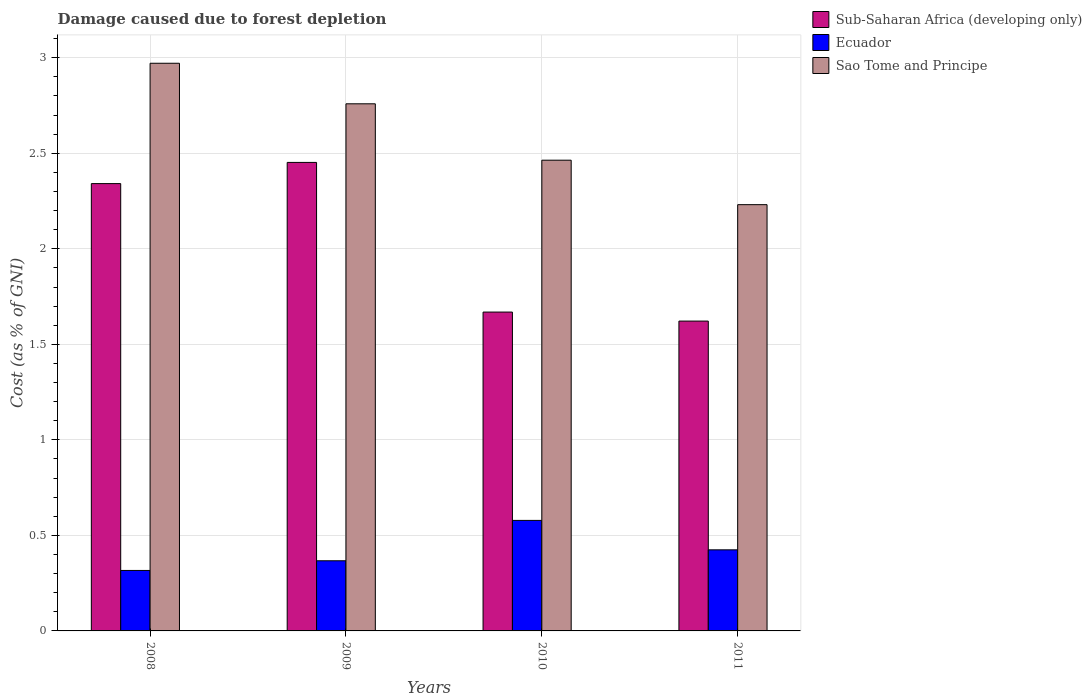How many bars are there on the 1st tick from the left?
Offer a terse response. 3. How many bars are there on the 1st tick from the right?
Your answer should be compact. 3. In how many cases, is the number of bars for a given year not equal to the number of legend labels?
Keep it short and to the point. 0. What is the cost of damage caused due to forest depletion in Sub-Saharan Africa (developing only) in 2008?
Provide a short and direct response. 2.34. Across all years, what is the maximum cost of damage caused due to forest depletion in Sub-Saharan Africa (developing only)?
Keep it short and to the point. 2.45. Across all years, what is the minimum cost of damage caused due to forest depletion in Sao Tome and Principe?
Keep it short and to the point. 2.23. In which year was the cost of damage caused due to forest depletion in Ecuador maximum?
Offer a very short reply. 2010. In which year was the cost of damage caused due to forest depletion in Sao Tome and Principe minimum?
Your answer should be very brief. 2011. What is the total cost of damage caused due to forest depletion in Sao Tome and Principe in the graph?
Your answer should be compact. 10.42. What is the difference between the cost of damage caused due to forest depletion in Sub-Saharan Africa (developing only) in 2008 and that in 2010?
Keep it short and to the point. 0.67. What is the difference between the cost of damage caused due to forest depletion in Ecuador in 2010 and the cost of damage caused due to forest depletion in Sao Tome and Principe in 2009?
Your answer should be very brief. -2.18. What is the average cost of damage caused due to forest depletion in Sub-Saharan Africa (developing only) per year?
Make the answer very short. 2.02. In the year 2009, what is the difference between the cost of damage caused due to forest depletion in Sub-Saharan Africa (developing only) and cost of damage caused due to forest depletion in Sao Tome and Principe?
Offer a terse response. -0.31. What is the ratio of the cost of damage caused due to forest depletion in Ecuador in 2010 to that in 2011?
Provide a succinct answer. 1.36. Is the cost of damage caused due to forest depletion in Sub-Saharan Africa (developing only) in 2009 less than that in 2010?
Keep it short and to the point. No. Is the difference between the cost of damage caused due to forest depletion in Sub-Saharan Africa (developing only) in 2009 and 2010 greater than the difference between the cost of damage caused due to forest depletion in Sao Tome and Principe in 2009 and 2010?
Your response must be concise. Yes. What is the difference between the highest and the second highest cost of damage caused due to forest depletion in Ecuador?
Ensure brevity in your answer.  0.15. What is the difference between the highest and the lowest cost of damage caused due to forest depletion in Sao Tome and Principe?
Give a very brief answer. 0.74. In how many years, is the cost of damage caused due to forest depletion in Sao Tome and Principe greater than the average cost of damage caused due to forest depletion in Sao Tome and Principe taken over all years?
Your answer should be compact. 2. What does the 2nd bar from the left in 2009 represents?
Make the answer very short. Ecuador. What does the 2nd bar from the right in 2011 represents?
Your response must be concise. Ecuador. Are all the bars in the graph horizontal?
Give a very brief answer. No. Does the graph contain any zero values?
Your answer should be compact. No. What is the title of the graph?
Your answer should be very brief. Damage caused due to forest depletion. What is the label or title of the X-axis?
Keep it short and to the point. Years. What is the label or title of the Y-axis?
Provide a succinct answer. Cost (as % of GNI). What is the Cost (as % of GNI) in Sub-Saharan Africa (developing only) in 2008?
Your answer should be compact. 2.34. What is the Cost (as % of GNI) in Ecuador in 2008?
Your answer should be compact. 0.32. What is the Cost (as % of GNI) of Sao Tome and Principe in 2008?
Provide a succinct answer. 2.97. What is the Cost (as % of GNI) in Sub-Saharan Africa (developing only) in 2009?
Provide a short and direct response. 2.45. What is the Cost (as % of GNI) in Ecuador in 2009?
Offer a terse response. 0.37. What is the Cost (as % of GNI) of Sao Tome and Principe in 2009?
Provide a succinct answer. 2.76. What is the Cost (as % of GNI) of Sub-Saharan Africa (developing only) in 2010?
Ensure brevity in your answer.  1.67. What is the Cost (as % of GNI) of Ecuador in 2010?
Offer a very short reply. 0.58. What is the Cost (as % of GNI) of Sao Tome and Principe in 2010?
Keep it short and to the point. 2.46. What is the Cost (as % of GNI) in Sub-Saharan Africa (developing only) in 2011?
Provide a short and direct response. 1.62. What is the Cost (as % of GNI) of Ecuador in 2011?
Give a very brief answer. 0.42. What is the Cost (as % of GNI) of Sao Tome and Principe in 2011?
Your answer should be very brief. 2.23. Across all years, what is the maximum Cost (as % of GNI) of Sub-Saharan Africa (developing only)?
Your response must be concise. 2.45. Across all years, what is the maximum Cost (as % of GNI) of Ecuador?
Your response must be concise. 0.58. Across all years, what is the maximum Cost (as % of GNI) in Sao Tome and Principe?
Your answer should be very brief. 2.97. Across all years, what is the minimum Cost (as % of GNI) of Sub-Saharan Africa (developing only)?
Offer a terse response. 1.62. Across all years, what is the minimum Cost (as % of GNI) of Ecuador?
Offer a terse response. 0.32. Across all years, what is the minimum Cost (as % of GNI) of Sao Tome and Principe?
Provide a succinct answer. 2.23. What is the total Cost (as % of GNI) of Sub-Saharan Africa (developing only) in the graph?
Your response must be concise. 8.08. What is the total Cost (as % of GNI) in Ecuador in the graph?
Offer a very short reply. 1.69. What is the total Cost (as % of GNI) of Sao Tome and Principe in the graph?
Provide a short and direct response. 10.42. What is the difference between the Cost (as % of GNI) of Sub-Saharan Africa (developing only) in 2008 and that in 2009?
Provide a succinct answer. -0.11. What is the difference between the Cost (as % of GNI) of Ecuador in 2008 and that in 2009?
Ensure brevity in your answer.  -0.05. What is the difference between the Cost (as % of GNI) of Sao Tome and Principe in 2008 and that in 2009?
Offer a very short reply. 0.21. What is the difference between the Cost (as % of GNI) in Sub-Saharan Africa (developing only) in 2008 and that in 2010?
Your answer should be very brief. 0.67. What is the difference between the Cost (as % of GNI) in Ecuador in 2008 and that in 2010?
Your answer should be compact. -0.26. What is the difference between the Cost (as % of GNI) of Sao Tome and Principe in 2008 and that in 2010?
Your response must be concise. 0.51. What is the difference between the Cost (as % of GNI) in Sub-Saharan Africa (developing only) in 2008 and that in 2011?
Keep it short and to the point. 0.72. What is the difference between the Cost (as % of GNI) in Ecuador in 2008 and that in 2011?
Your answer should be compact. -0.11. What is the difference between the Cost (as % of GNI) in Sao Tome and Principe in 2008 and that in 2011?
Your answer should be very brief. 0.74. What is the difference between the Cost (as % of GNI) of Sub-Saharan Africa (developing only) in 2009 and that in 2010?
Your answer should be compact. 0.78. What is the difference between the Cost (as % of GNI) of Ecuador in 2009 and that in 2010?
Your answer should be compact. -0.21. What is the difference between the Cost (as % of GNI) of Sao Tome and Principe in 2009 and that in 2010?
Your response must be concise. 0.3. What is the difference between the Cost (as % of GNI) in Sub-Saharan Africa (developing only) in 2009 and that in 2011?
Offer a terse response. 0.83. What is the difference between the Cost (as % of GNI) in Ecuador in 2009 and that in 2011?
Provide a succinct answer. -0.06. What is the difference between the Cost (as % of GNI) of Sao Tome and Principe in 2009 and that in 2011?
Offer a terse response. 0.53. What is the difference between the Cost (as % of GNI) in Sub-Saharan Africa (developing only) in 2010 and that in 2011?
Your response must be concise. 0.05. What is the difference between the Cost (as % of GNI) in Ecuador in 2010 and that in 2011?
Your response must be concise. 0.15. What is the difference between the Cost (as % of GNI) of Sao Tome and Principe in 2010 and that in 2011?
Make the answer very short. 0.23. What is the difference between the Cost (as % of GNI) of Sub-Saharan Africa (developing only) in 2008 and the Cost (as % of GNI) of Ecuador in 2009?
Your answer should be very brief. 1.97. What is the difference between the Cost (as % of GNI) of Sub-Saharan Africa (developing only) in 2008 and the Cost (as % of GNI) of Sao Tome and Principe in 2009?
Provide a succinct answer. -0.42. What is the difference between the Cost (as % of GNI) of Ecuador in 2008 and the Cost (as % of GNI) of Sao Tome and Principe in 2009?
Offer a terse response. -2.44. What is the difference between the Cost (as % of GNI) in Sub-Saharan Africa (developing only) in 2008 and the Cost (as % of GNI) in Ecuador in 2010?
Ensure brevity in your answer.  1.76. What is the difference between the Cost (as % of GNI) in Sub-Saharan Africa (developing only) in 2008 and the Cost (as % of GNI) in Sao Tome and Principe in 2010?
Offer a very short reply. -0.12. What is the difference between the Cost (as % of GNI) in Ecuador in 2008 and the Cost (as % of GNI) in Sao Tome and Principe in 2010?
Your answer should be compact. -2.15. What is the difference between the Cost (as % of GNI) in Sub-Saharan Africa (developing only) in 2008 and the Cost (as % of GNI) in Ecuador in 2011?
Your response must be concise. 1.92. What is the difference between the Cost (as % of GNI) in Sub-Saharan Africa (developing only) in 2008 and the Cost (as % of GNI) in Sao Tome and Principe in 2011?
Provide a short and direct response. 0.11. What is the difference between the Cost (as % of GNI) of Ecuador in 2008 and the Cost (as % of GNI) of Sao Tome and Principe in 2011?
Your answer should be very brief. -1.91. What is the difference between the Cost (as % of GNI) of Sub-Saharan Africa (developing only) in 2009 and the Cost (as % of GNI) of Ecuador in 2010?
Provide a succinct answer. 1.87. What is the difference between the Cost (as % of GNI) of Sub-Saharan Africa (developing only) in 2009 and the Cost (as % of GNI) of Sao Tome and Principe in 2010?
Your answer should be compact. -0.01. What is the difference between the Cost (as % of GNI) of Ecuador in 2009 and the Cost (as % of GNI) of Sao Tome and Principe in 2010?
Your answer should be compact. -2.1. What is the difference between the Cost (as % of GNI) in Sub-Saharan Africa (developing only) in 2009 and the Cost (as % of GNI) in Ecuador in 2011?
Your response must be concise. 2.03. What is the difference between the Cost (as % of GNI) of Sub-Saharan Africa (developing only) in 2009 and the Cost (as % of GNI) of Sao Tome and Principe in 2011?
Provide a short and direct response. 0.22. What is the difference between the Cost (as % of GNI) of Ecuador in 2009 and the Cost (as % of GNI) of Sao Tome and Principe in 2011?
Make the answer very short. -1.86. What is the difference between the Cost (as % of GNI) in Sub-Saharan Africa (developing only) in 2010 and the Cost (as % of GNI) in Ecuador in 2011?
Ensure brevity in your answer.  1.24. What is the difference between the Cost (as % of GNI) of Sub-Saharan Africa (developing only) in 2010 and the Cost (as % of GNI) of Sao Tome and Principe in 2011?
Offer a terse response. -0.56. What is the difference between the Cost (as % of GNI) of Ecuador in 2010 and the Cost (as % of GNI) of Sao Tome and Principe in 2011?
Provide a succinct answer. -1.65. What is the average Cost (as % of GNI) of Sub-Saharan Africa (developing only) per year?
Your answer should be very brief. 2.02. What is the average Cost (as % of GNI) of Ecuador per year?
Offer a terse response. 0.42. What is the average Cost (as % of GNI) in Sao Tome and Principe per year?
Your response must be concise. 2.61. In the year 2008, what is the difference between the Cost (as % of GNI) in Sub-Saharan Africa (developing only) and Cost (as % of GNI) in Ecuador?
Offer a very short reply. 2.02. In the year 2008, what is the difference between the Cost (as % of GNI) in Sub-Saharan Africa (developing only) and Cost (as % of GNI) in Sao Tome and Principe?
Provide a succinct answer. -0.63. In the year 2008, what is the difference between the Cost (as % of GNI) of Ecuador and Cost (as % of GNI) of Sao Tome and Principe?
Provide a short and direct response. -2.65. In the year 2009, what is the difference between the Cost (as % of GNI) in Sub-Saharan Africa (developing only) and Cost (as % of GNI) in Ecuador?
Your answer should be compact. 2.08. In the year 2009, what is the difference between the Cost (as % of GNI) in Sub-Saharan Africa (developing only) and Cost (as % of GNI) in Sao Tome and Principe?
Your response must be concise. -0.31. In the year 2009, what is the difference between the Cost (as % of GNI) in Ecuador and Cost (as % of GNI) in Sao Tome and Principe?
Offer a terse response. -2.39. In the year 2010, what is the difference between the Cost (as % of GNI) in Sub-Saharan Africa (developing only) and Cost (as % of GNI) in Ecuador?
Offer a very short reply. 1.09. In the year 2010, what is the difference between the Cost (as % of GNI) of Sub-Saharan Africa (developing only) and Cost (as % of GNI) of Sao Tome and Principe?
Your answer should be compact. -0.79. In the year 2010, what is the difference between the Cost (as % of GNI) of Ecuador and Cost (as % of GNI) of Sao Tome and Principe?
Offer a very short reply. -1.89. In the year 2011, what is the difference between the Cost (as % of GNI) in Sub-Saharan Africa (developing only) and Cost (as % of GNI) in Ecuador?
Offer a very short reply. 1.2. In the year 2011, what is the difference between the Cost (as % of GNI) in Sub-Saharan Africa (developing only) and Cost (as % of GNI) in Sao Tome and Principe?
Offer a terse response. -0.61. In the year 2011, what is the difference between the Cost (as % of GNI) of Ecuador and Cost (as % of GNI) of Sao Tome and Principe?
Offer a very short reply. -1.81. What is the ratio of the Cost (as % of GNI) of Sub-Saharan Africa (developing only) in 2008 to that in 2009?
Give a very brief answer. 0.95. What is the ratio of the Cost (as % of GNI) in Ecuador in 2008 to that in 2009?
Make the answer very short. 0.86. What is the ratio of the Cost (as % of GNI) in Sao Tome and Principe in 2008 to that in 2009?
Offer a terse response. 1.08. What is the ratio of the Cost (as % of GNI) of Sub-Saharan Africa (developing only) in 2008 to that in 2010?
Provide a succinct answer. 1.4. What is the ratio of the Cost (as % of GNI) in Ecuador in 2008 to that in 2010?
Offer a terse response. 0.55. What is the ratio of the Cost (as % of GNI) in Sao Tome and Principe in 2008 to that in 2010?
Ensure brevity in your answer.  1.21. What is the ratio of the Cost (as % of GNI) of Sub-Saharan Africa (developing only) in 2008 to that in 2011?
Offer a terse response. 1.44. What is the ratio of the Cost (as % of GNI) in Ecuador in 2008 to that in 2011?
Give a very brief answer. 0.75. What is the ratio of the Cost (as % of GNI) in Sao Tome and Principe in 2008 to that in 2011?
Your answer should be very brief. 1.33. What is the ratio of the Cost (as % of GNI) in Sub-Saharan Africa (developing only) in 2009 to that in 2010?
Your response must be concise. 1.47. What is the ratio of the Cost (as % of GNI) of Ecuador in 2009 to that in 2010?
Offer a terse response. 0.63. What is the ratio of the Cost (as % of GNI) of Sao Tome and Principe in 2009 to that in 2010?
Offer a very short reply. 1.12. What is the ratio of the Cost (as % of GNI) in Sub-Saharan Africa (developing only) in 2009 to that in 2011?
Your answer should be very brief. 1.51. What is the ratio of the Cost (as % of GNI) in Ecuador in 2009 to that in 2011?
Provide a short and direct response. 0.87. What is the ratio of the Cost (as % of GNI) in Sao Tome and Principe in 2009 to that in 2011?
Offer a terse response. 1.24. What is the ratio of the Cost (as % of GNI) in Sub-Saharan Africa (developing only) in 2010 to that in 2011?
Your answer should be compact. 1.03. What is the ratio of the Cost (as % of GNI) in Ecuador in 2010 to that in 2011?
Make the answer very short. 1.36. What is the ratio of the Cost (as % of GNI) in Sao Tome and Principe in 2010 to that in 2011?
Provide a short and direct response. 1.1. What is the difference between the highest and the second highest Cost (as % of GNI) of Sub-Saharan Africa (developing only)?
Keep it short and to the point. 0.11. What is the difference between the highest and the second highest Cost (as % of GNI) of Ecuador?
Offer a very short reply. 0.15. What is the difference between the highest and the second highest Cost (as % of GNI) in Sao Tome and Principe?
Provide a short and direct response. 0.21. What is the difference between the highest and the lowest Cost (as % of GNI) of Sub-Saharan Africa (developing only)?
Your answer should be compact. 0.83. What is the difference between the highest and the lowest Cost (as % of GNI) of Ecuador?
Offer a very short reply. 0.26. What is the difference between the highest and the lowest Cost (as % of GNI) of Sao Tome and Principe?
Your answer should be very brief. 0.74. 